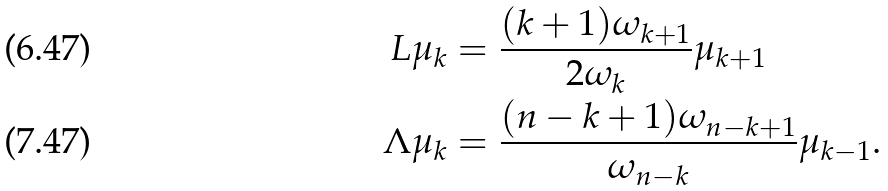Convert formula to latex. <formula><loc_0><loc_0><loc_500><loc_500>L \mu _ { k } & = \frac { ( k + 1 ) \omega _ { k + 1 } } { 2 \omega _ { k } } \mu _ { k + 1 } \\ \Lambda \mu _ { k } & = \frac { ( n - k + 1 ) \omega _ { n - k + 1 } } { \omega _ { n - k } } \mu _ { k - 1 } .</formula> 